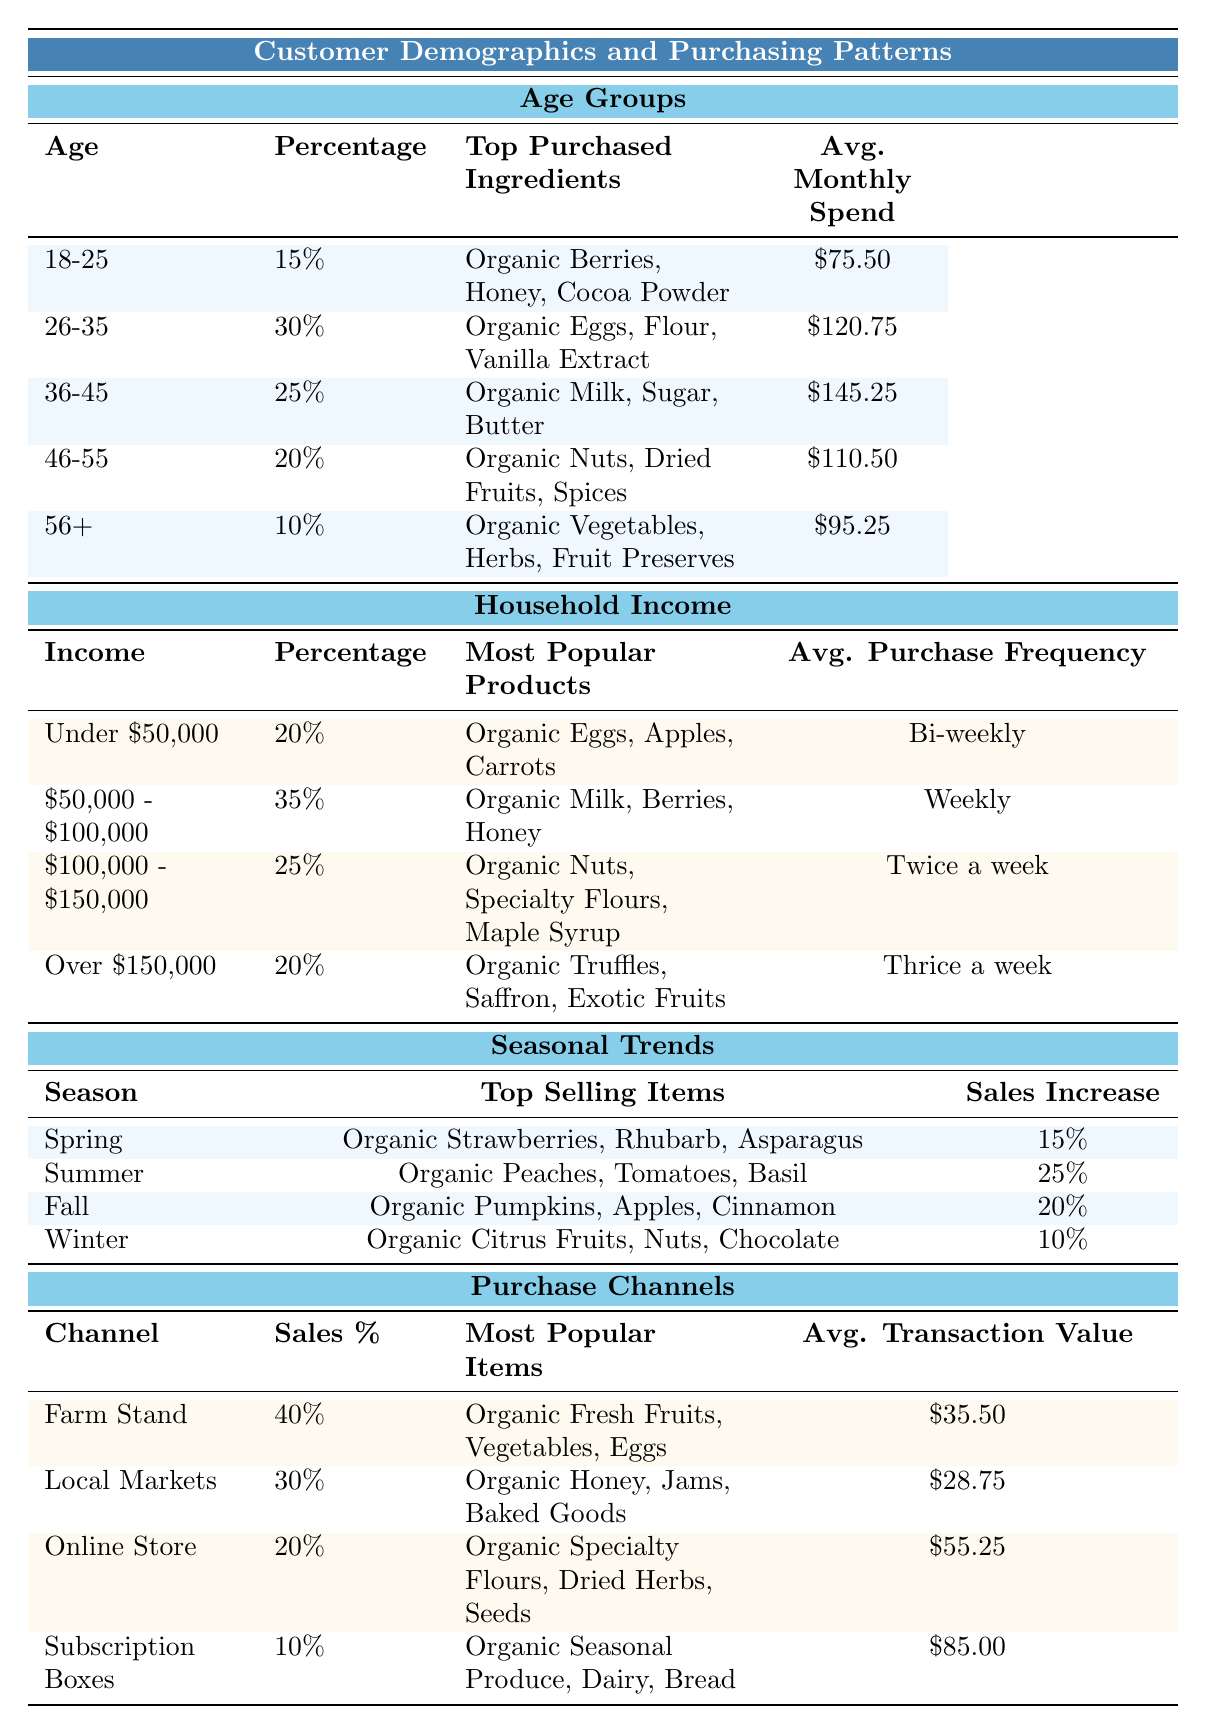What age group has the highest percentage of customers? The age group with the highest percentage is 26-35, which has 30%.
Answer: 26-35 What are the top three purchased ingredients for the 36-45 age group? The top purchased ingredients for the 36-45 age group are Organic Milk, Organic Sugar, and Organic Butter.
Answer: Organic Milk, Organic Sugar, Organic Butter What is the average monthly spend for customers aged 46-55? The average monthly spend for customers aged 46-55 is $110.50.
Answer: $110.50 Which income group spends on organic truffles, saffron, and exotic fruits? The income group that spends on these items is Over $150,000.
Answer: Over $150,000 What is the percentage of sales from the Farm Stand channel? The percentage of sales from the Farm Stand channel is 40%.
Answer: 40% Which season shows the highest sales increase and by how much? Summer shows the highest sales increase of 25%.
Answer: 25% Which group has the lowest average monthly spend? The age group with the lowest average monthly spend is 56+, with a spend of $95.25.
Answer: 56+ How often do customers in the $100,000 - $150,000 income group make purchases? Customers in this income group purchase twice a week.
Answer: Twice a week What is the combined percentage of sales from the Farm Stand and Local Markets channels? The combined percentage is 70% (40% from the Farm Stand + 30% from Local Markets).
Answer: 70% Do customers aged 18-25 spend more than those aged 56+? Yes, customers aged 18-25 spend $75.50, which is more than the $95.25 spent by those aged 56+.
Answer: Yes Which topping ingredients are most popular in the fall season? The most popular topping ingredients in the fall season are Organic Pumpkins, Organic Apples, and Organic Cinnamon.
Answer: Organic Pumpkins, Organic Apples, Organic Cinnamon What is the average transaction value for purchases made through Subscription Boxes? The average transaction value for Subscription Boxes is $85.00.
Answer: $85.00 How much more do customers aged 36-45 spend on average compared to those aged 18-25? Customers aged 36-45 spend $145.25, while those aged 18-25 spend $75.50, a difference of $69.75.
Answer: $69.75 Are organic vegetables, herbs, and fruit preserves purchased more by older customers? Yes, these ingredients are the top purchased items by the 56+ age group.
Answer: Yes Which product category leads in purchase frequency for the income group under $50,000? The income group under $50,000 purchases Organic Eggs, Apples, and Carrots bi-weekly.
Answer: Bi-weekly 